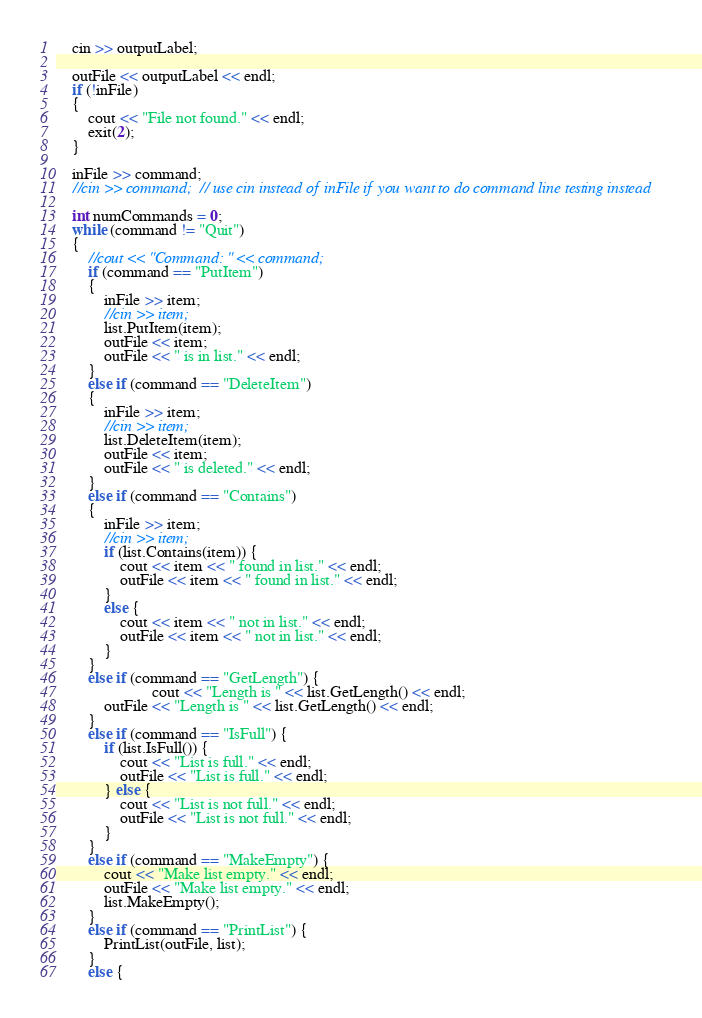<code> <loc_0><loc_0><loc_500><loc_500><_C++_>	cin >> outputLabel;

	outFile << outputLabel << endl;
	if (!inFile)
	{
		cout << "File not found." << endl;
		exit(2);
	}

	inFile >> command;
	//cin >> command;  // use cin instead of inFile if you want to do command line testing instead

	int numCommands = 0;
	while (command != "Quit")
	{
		//cout << "Command: " << command;
		if (command == "PutItem")
		{
			inFile >> item;
			//cin >> item;
			list.PutItem(item);
			outFile << item;
			outFile << " is in list." << endl;
		}
		else if (command == "DeleteItem")
		{
			inFile >> item;
			//cin >> item;
			list.DeleteItem(item);
			outFile << item;
			outFile << " is deleted." << endl;
		}
		else if (command == "Contains")
		{
			inFile >> item;
			//cin >> item;
			if (list.Contains(item)) {
				cout << item << " found in list." << endl;
				outFile << item << " found in list." << endl;
			}
			else {
				cout << item << " not in list." << endl;
				outFile << item << " not in list." << endl;
			}
		}
		else if (command == "GetLength") {
                        cout << "Length is " << list.GetLength() << endl;
			outFile << "Length is " << list.GetLength() << endl;
		}
		else if (command == "IsFull") {
			if (list.IsFull()) {
                cout << "List is full." << endl;
                outFile << "List is full." << endl;
            } else {
                cout << "List is not full." << endl;
                outFile << "List is not full." << endl;
            }
		}
		else if (command == "MakeEmpty") {
            cout << "Make list empty." << endl;
            outFile << "Make list empty." << endl;
			list.MakeEmpty();
		}
		else if (command == "PrintList") {
			PrintList(outFile, list);
		}
		else {</code> 